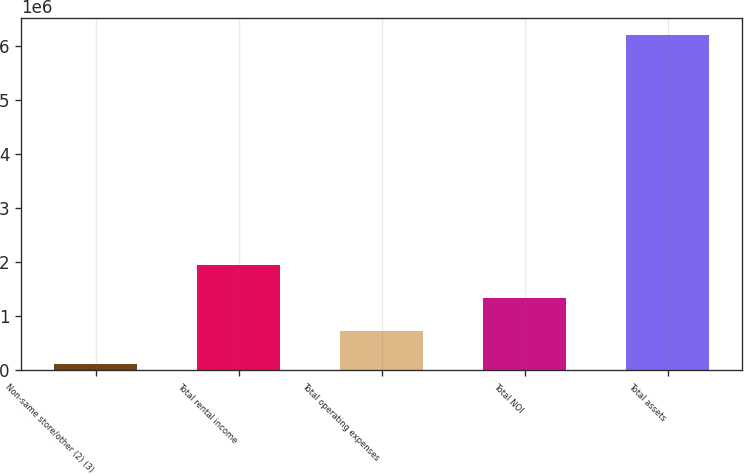Convert chart. <chart><loc_0><loc_0><loc_500><loc_500><bar_chart><fcel>Non-same store/other (2) (3)<fcel>Total rental income<fcel>Total operating expenses<fcel>Total NOI<fcel>Total assets<nl><fcel>112747<fcel>1.94238e+06<fcel>722626<fcel>1.3325e+06<fcel>6.21153e+06<nl></chart> 